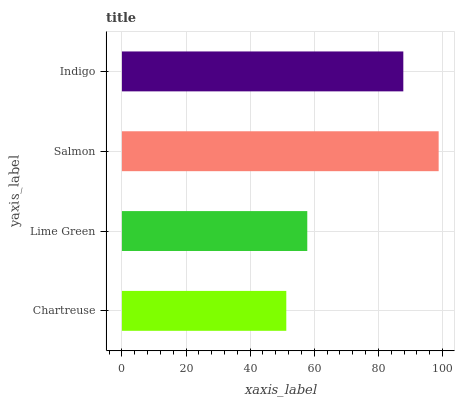Is Chartreuse the minimum?
Answer yes or no. Yes. Is Salmon the maximum?
Answer yes or no. Yes. Is Lime Green the minimum?
Answer yes or no. No. Is Lime Green the maximum?
Answer yes or no. No. Is Lime Green greater than Chartreuse?
Answer yes or no. Yes. Is Chartreuse less than Lime Green?
Answer yes or no. Yes. Is Chartreuse greater than Lime Green?
Answer yes or no. No. Is Lime Green less than Chartreuse?
Answer yes or no. No. Is Indigo the high median?
Answer yes or no. Yes. Is Lime Green the low median?
Answer yes or no. Yes. Is Salmon the high median?
Answer yes or no. No. Is Chartreuse the low median?
Answer yes or no. No. 